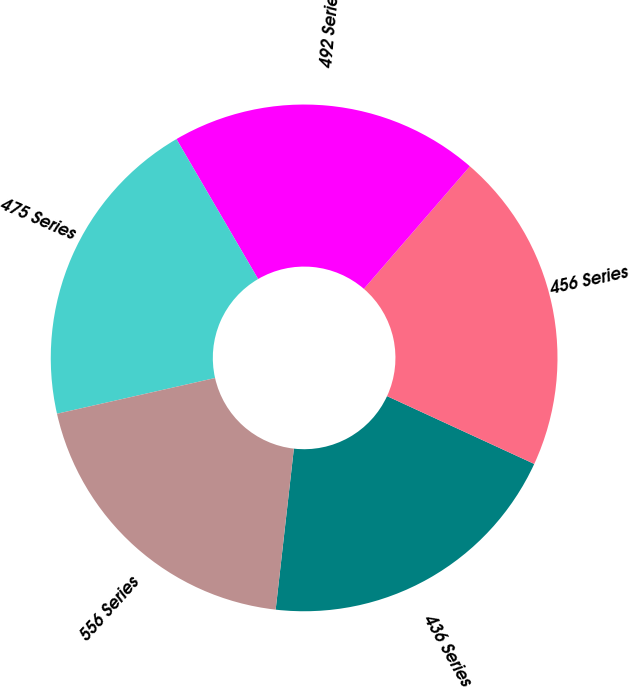Convert chart. <chart><loc_0><loc_0><loc_500><loc_500><pie_chart><fcel>436 Series<fcel>456 Series<fcel>492 Series<fcel>475 Series<fcel>556 Series<nl><fcel>19.92%<fcel>20.52%<fcel>19.76%<fcel>20.13%<fcel>19.67%<nl></chart> 